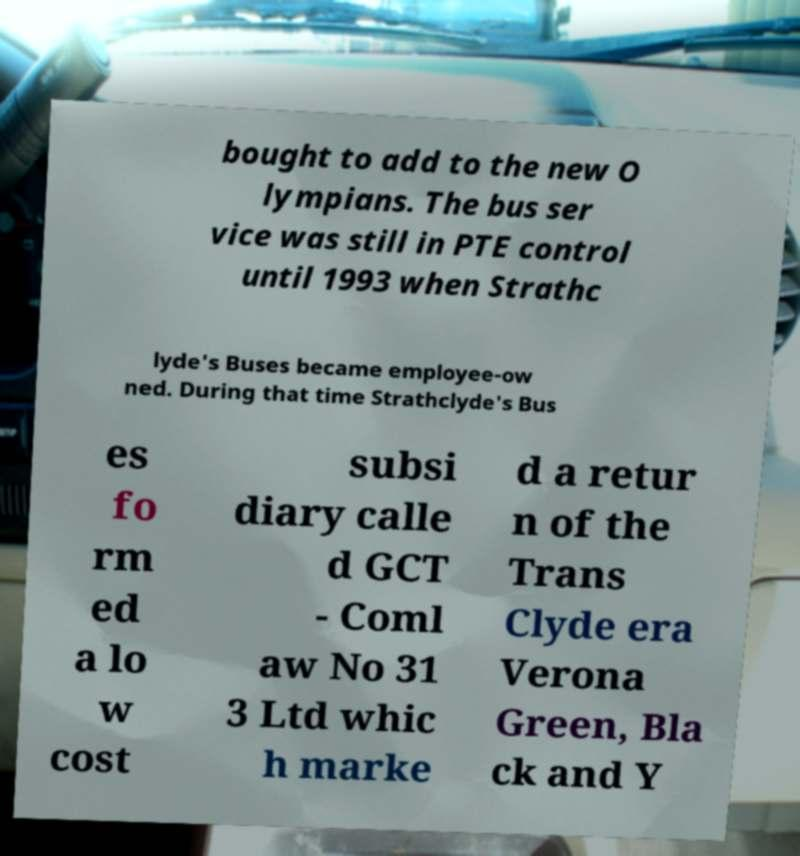There's text embedded in this image that I need extracted. Can you transcribe it verbatim? bought to add to the new O lympians. The bus ser vice was still in PTE control until 1993 when Strathc lyde's Buses became employee-ow ned. During that time Strathclyde's Bus es fo rm ed a lo w cost subsi diary calle d GCT - Coml aw No 31 3 Ltd whic h marke d a retur n of the Trans Clyde era Verona Green, Bla ck and Y 